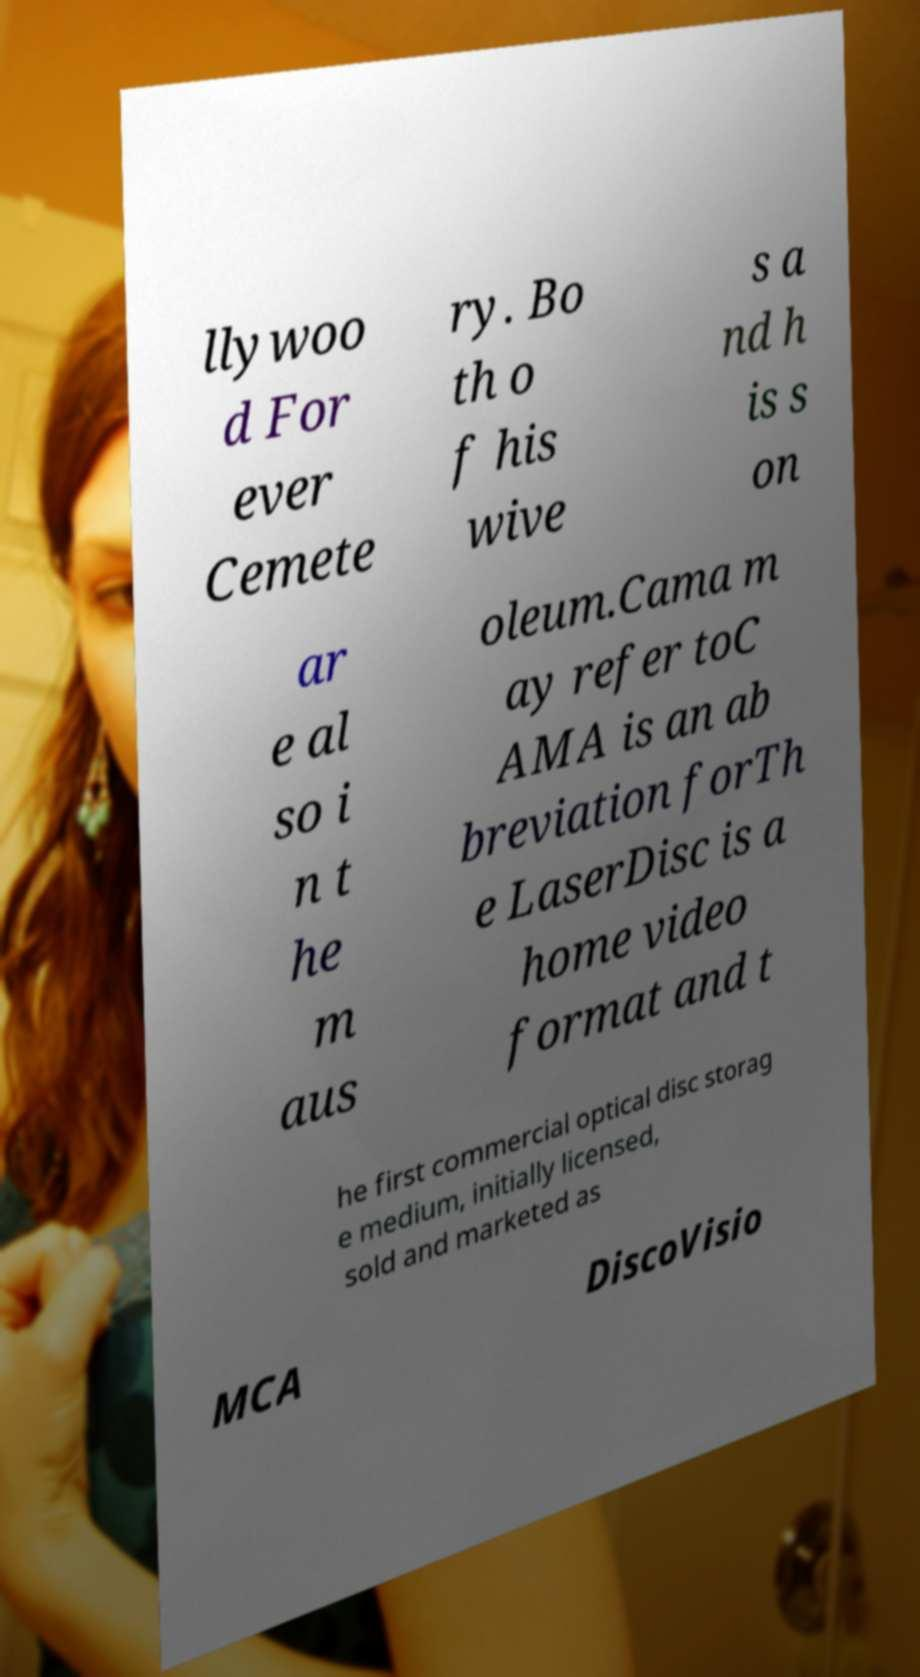For documentation purposes, I need the text within this image transcribed. Could you provide that? llywoo d For ever Cemete ry. Bo th o f his wive s a nd h is s on ar e al so i n t he m aus oleum.Cama m ay refer toC AMA is an ab breviation forTh e LaserDisc is a home video format and t he first commercial optical disc storag e medium, initially licensed, sold and marketed as MCA DiscoVisio 